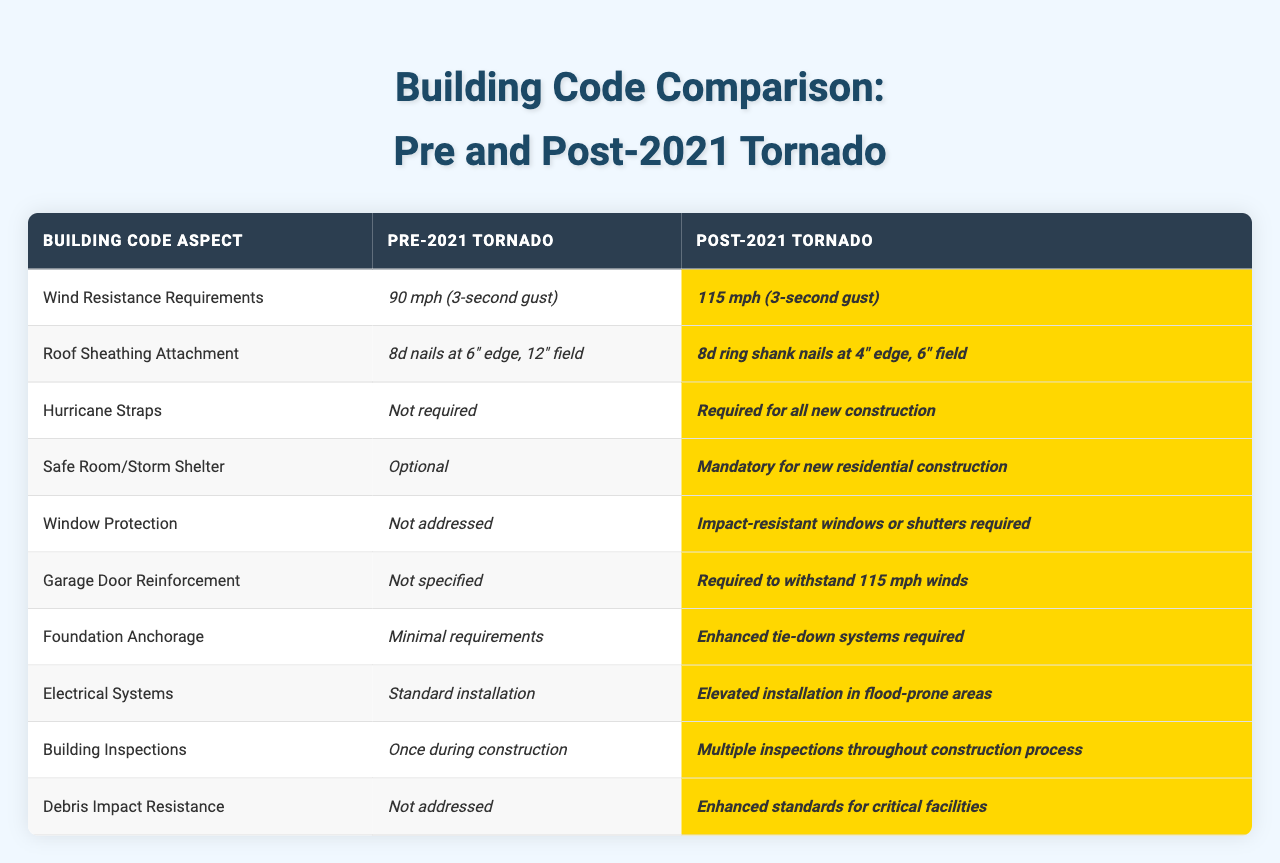What are the wind resistance requirements before the tornado? The table states that the wind resistance requirements prior to the 2021 tornado were 90 mph for a 3-second gust.
Answer: 90 mph Is the use of hurricane straps required for all new constructions after the tornado? According to the table, hurricane straps were not required before the tornado, but they are mandatory for all new constructions after the tornado.
Answer: Yes What changed in the requirements for roof sheathing attachment from pre to post-tornado? The table indicates that prior to the tornado, 8d nails were used at a spacing of 6 inches on the edge and 12 inches in the field, while after the tornado, 8d ring shank nails are now required at 4 inches on the edge and 6 inches in the field.
Answer: More stringent requirements How many building inspections are conducted during construction after the tornado? The table specifies that there are multiple inspections conducted throughout the construction process after the tornado, compared to only one inspection during construction before the tornado.
Answer: Multiple inspections Is there a requirement for storm shelters in new constructions post-tornado? The table shows that before the tornado, storm shelters were optional, but they are now mandatory for new residential construction following the tornado.
Answer: Yes What is the difference in debris impact resistance standards pre and post-tornado? Prior to the tornado, debris impact resistance was not addressed, whereas post-tornado, there are enhanced standards established for critical facilities regarding debris impact resistance.
Answer: Enhanced standards What materials or methods are required for garage door reinforcement after the tornado? The table indicates that garage door reinforcement was not specified before the tornado, but it is now required to withstand winds of 115 mph after the tornado.
Answer: Required for 115 mph How do the foundation anchorage requirements compare before and after the tornado? Before the tornado, the foundation anchorage had minimal requirements, while after the tornado, enhanced tie-down systems are required, indicating a significant increase in strength and resilience expectations.
Answer: Enhanced tie-down systems required What are the electrical system installation requirements in flood-prone areas post-tornado? The table states that while standard installation was followed before the tornado, now electrical systems must be installed at elevated levels in areas prone to flooding after the tornado.
Answer: Elevated installation How much has the wind resistance requirement increased from pre to post-tornado? The wind resistance requirement increased from 90 mph to 115 mph, representing a difference of 25 mph, indicating a stronger emphasis on wind resistance in the revised codes.
Answer: Increased by 25 mph 